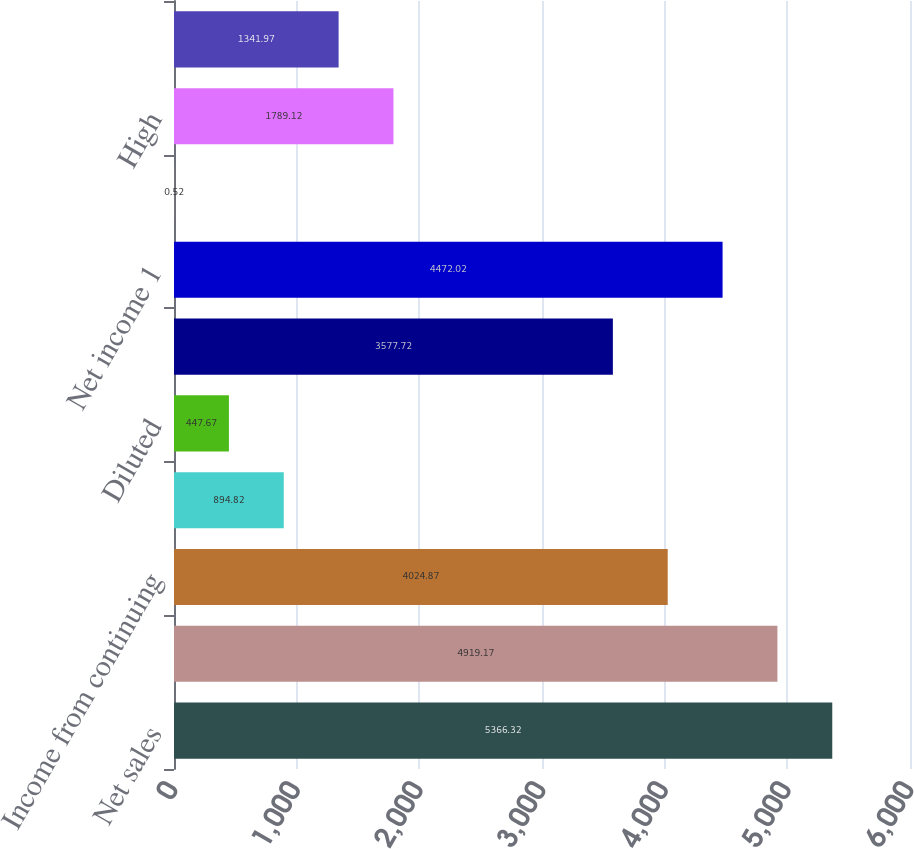Convert chart to OTSL. <chart><loc_0><loc_0><loc_500><loc_500><bar_chart><fcel>Net sales<fcel>Gross margin<fcel>Income from continuing<fcel>Basic<fcel>Diluted<fcel>Income from discontinued<fcel>Net income 1<fcel>Cash dividends declared per<fcel>High<fcel>Low<nl><fcel>5366.32<fcel>4919.17<fcel>4024.87<fcel>894.82<fcel>447.67<fcel>3577.72<fcel>4472.02<fcel>0.52<fcel>1789.12<fcel>1341.97<nl></chart> 